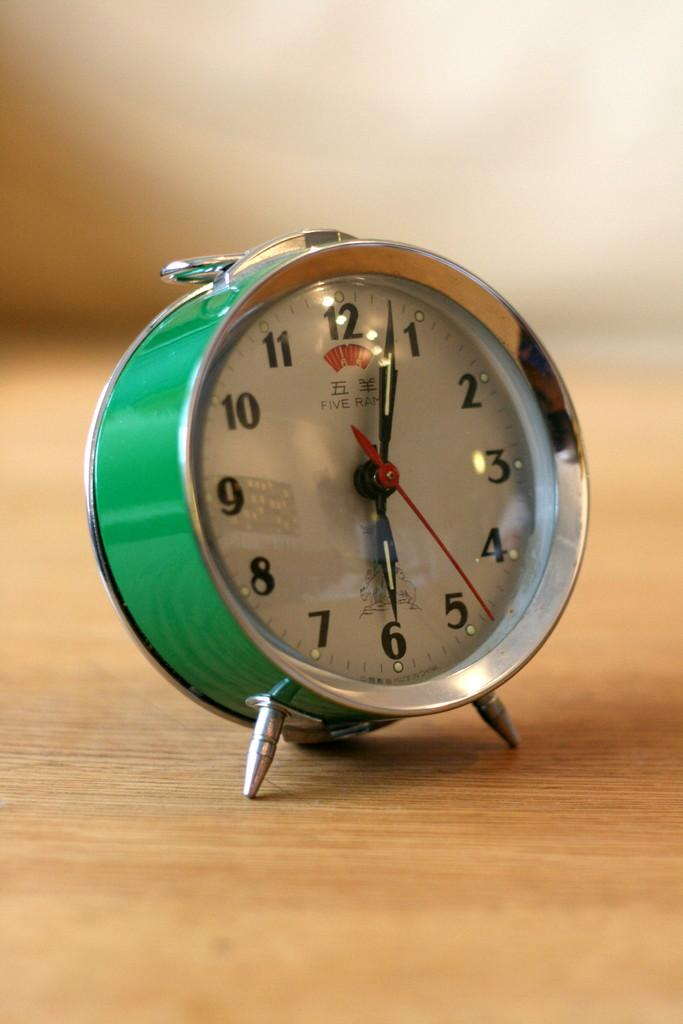<image>
Summarize the visual content of the image. a green clock with the dials pointing at 1 and 6 